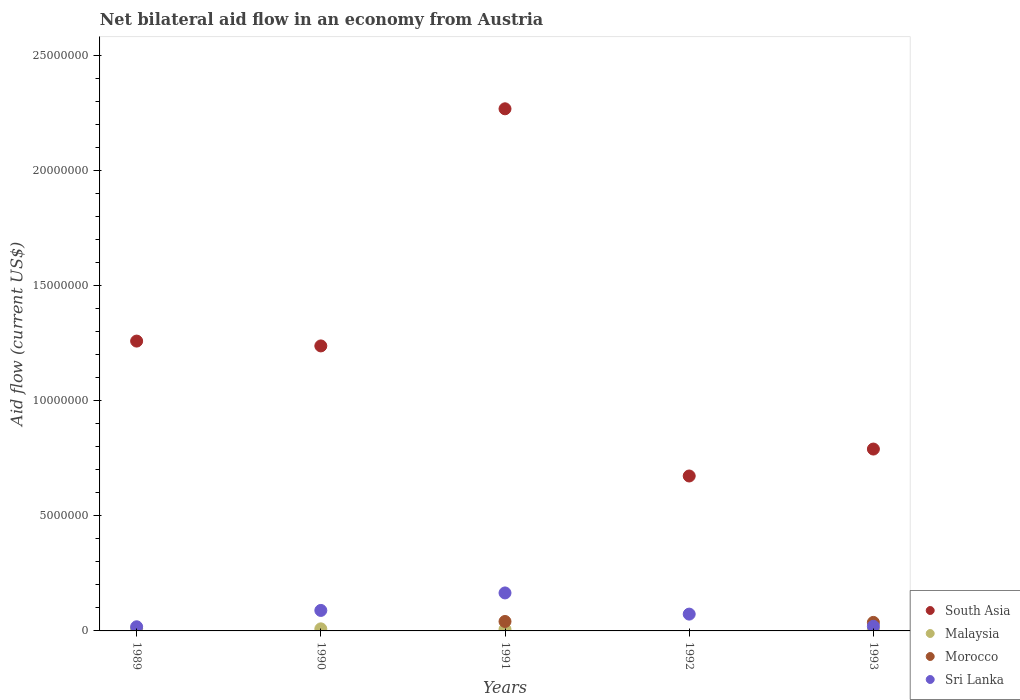Is the number of dotlines equal to the number of legend labels?
Offer a terse response. No. What is the net bilateral aid flow in Sri Lanka in 1991?
Provide a short and direct response. 1.65e+06. Across all years, what is the minimum net bilateral aid flow in South Asia?
Provide a short and direct response. 6.73e+06. What is the total net bilateral aid flow in Morocco in the graph?
Your answer should be compact. 7.80e+05. What is the difference between the net bilateral aid flow in South Asia in 1990 and that in 1991?
Your answer should be compact. -1.03e+07. What is the difference between the net bilateral aid flow in Sri Lanka in 1991 and the net bilateral aid flow in Morocco in 1990?
Keep it short and to the point. 1.65e+06. What is the average net bilateral aid flow in Malaysia per year?
Provide a short and direct response. 6.40e+04. In the year 1993, what is the difference between the net bilateral aid flow in Malaysia and net bilateral aid flow in Morocco?
Offer a terse response. -3.10e+05. In how many years, is the net bilateral aid flow in Sri Lanka greater than 16000000 US$?
Give a very brief answer. 0. What is the ratio of the net bilateral aid flow in South Asia in 1989 to that in 1990?
Keep it short and to the point. 1.02. What is the difference between the highest and the second highest net bilateral aid flow in South Asia?
Your answer should be compact. 1.01e+07. What is the difference between the highest and the lowest net bilateral aid flow in Sri Lanka?
Provide a short and direct response. 1.47e+06. In how many years, is the net bilateral aid flow in Sri Lanka greater than the average net bilateral aid flow in Sri Lanka taken over all years?
Offer a terse response. 2. How many dotlines are there?
Offer a terse response. 4. How many years are there in the graph?
Offer a terse response. 5. Are the values on the major ticks of Y-axis written in scientific E-notation?
Ensure brevity in your answer.  No. Does the graph contain grids?
Make the answer very short. No. Where does the legend appear in the graph?
Your answer should be compact. Bottom right. How many legend labels are there?
Your answer should be very brief. 4. What is the title of the graph?
Your answer should be compact. Net bilateral aid flow in an economy from Austria. What is the label or title of the X-axis?
Your answer should be very brief. Years. What is the label or title of the Y-axis?
Offer a very short reply. Aid flow (current US$). What is the Aid flow (current US$) of South Asia in 1989?
Provide a short and direct response. 1.26e+07. What is the Aid flow (current US$) of Malaysia in 1989?
Give a very brief answer. 1.00e+05. What is the Aid flow (current US$) of Morocco in 1989?
Ensure brevity in your answer.  0. What is the Aid flow (current US$) of Sri Lanka in 1989?
Provide a short and direct response. 1.80e+05. What is the Aid flow (current US$) in South Asia in 1990?
Your answer should be compact. 1.24e+07. What is the Aid flow (current US$) of Malaysia in 1990?
Give a very brief answer. 9.00e+04. What is the Aid flow (current US$) in Sri Lanka in 1990?
Provide a short and direct response. 8.90e+05. What is the Aid flow (current US$) of South Asia in 1991?
Keep it short and to the point. 2.27e+07. What is the Aid flow (current US$) in Malaysia in 1991?
Give a very brief answer. 7.00e+04. What is the Aid flow (current US$) of Sri Lanka in 1991?
Keep it short and to the point. 1.65e+06. What is the Aid flow (current US$) of South Asia in 1992?
Make the answer very short. 6.73e+06. What is the Aid flow (current US$) in Malaysia in 1992?
Offer a terse response. 0. What is the Aid flow (current US$) of Morocco in 1992?
Ensure brevity in your answer.  0. What is the Aid flow (current US$) in Sri Lanka in 1992?
Make the answer very short. 7.30e+05. What is the Aid flow (current US$) of South Asia in 1993?
Your response must be concise. 7.90e+06. What is the Aid flow (current US$) in Morocco in 1993?
Your response must be concise. 3.70e+05. Across all years, what is the maximum Aid flow (current US$) in South Asia?
Your response must be concise. 2.27e+07. Across all years, what is the maximum Aid flow (current US$) of Malaysia?
Your answer should be very brief. 1.00e+05. Across all years, what is the maximum Aid flow (current US$) of Morocco?
Your answer should be very brief. 4.10e+05. Across all years, what is the maximum Aid flow (current US$) in Sri Lanka?
Your answer should be very brief. 1.65e+06. Across all years, what is the minimum Aid flow (current US$) in South Asia?
Provide a short and direct response. 6.73e+06. What is the total Aid flow (current US$) of South Asia in the graph?
Provide a short and direct response. 6.23e+07. What is the total Aid flow (current US$) of Morocco in the graph?
Make the answer very short. 7.80e+05. What is the total Aid flow (current US$) in Sri Lanka in the graph?
Provide a short and direct response. 3.65e+06. What is the difference between the Aid flow (current US$) of South Asia in 1989 and that in 1990?
Provide a short and direct response. 2.10e+05. What is the difference between the Aid flow (current US$) in Malaysia in 1989 and that in 1990?
Offer a terse response. 10000. What is the difference between the Aid flow (current US$) of Sri Lanka in 1989 and that in 1990?
Your response must be concise. -7.10e+05. What is the difference between the Aid flow (current US$) in South Asia in 1989 and that in 1991?
Make the answer very short. -1.01e+07. What is the difference between the Aid flow (current US$) of Sri Lanka in 1989 and that in 1991?
Give a very brief answer. -1.47e+06. What is the difference between the Aid flow (current US$) in South Asia in 1989 and that in 1992?
Offer a very short reply. 5.86e+06. What is the difference between the Aid flow (current US$) of Sri Lanka in 1989 and that in 1992?
Your answer should be very brief. -5.50e+05. What is the difference between the Aid flow (current US$) of South Asia in 1989 and that in 1993?
Provide a short and direct response. 4.69e+06. What is the difference between the Aid flow (current US$) of South Asia in 1990 and that in 1991?
Offer a very short reply. -1.03e+07. What is the difference between the Aid flow (current US$) of Malaysia in 1990 and that in 1991?
Provide a short and direct response. 2.00e+04. What is the difference between the Aid flow (current US$) in Sri Lanka in 1990 and that in 1991?
Your answer should be very brief. -7.60e+05. What is the difference between the Aid flow (current US$) of South Asia in 1990 and that in 1992?
Your response must be concise. 5.65e+06. What is the difference between the Aid flow (current US$) of South Asia in 1990 and that in 1993?
Make the answer very short. 4.48e+06. What is the difference between the Aid flow (current US$) in Sri Lanka in 1990 and that in 1993?
Your answer should be compact. 6.90e+05. What is the difference between the Aid flow (current US$) of South Asia in 1991 and that in 1992?
Your answer should be compact. 1.60e+07. What is the difference between the Aid flow (current US$) of Sri Lanka in 1991 and that in 1992?
Your answer should be compact. 9.20e+05. What is the difference between the Aid flow (current US$) of South Asia in 1991 and that in 1993?
Offer a terse response. 1.48e+07. What is the difference between the Aid flow (current US$) of Malaysia in 1991 and that in 1993?
Give a very brief answer. 10000. What is the difference between the Aid flow (current US$) in Sri Lanka in 1991 and that in 1993?
Your answer should be very brief. 1.45e+06. What is the difference between the Aid flow (current US$) in South Asia in 1992 and that in 1993?
Your response must be concise. -1.17e+06. What is the difference between the Aid flow (current US$) in Sri Lanka in 1992 and that in 1993?
Your answer should be compact. 5.30e+05. What is the difference between the Aid flow (current US$) in South Asia in 1989 and the Aid flow (current US$) in Malaysia in 1990?
Make the answer very short. 1.25e+07. What is the difference between the Aid flow (current US$) of South Asia in 1989 and the Aid flow (current US$) of Sri Lanka in 1990?
Ensure brevity in your answer.  1.17e+07. What is the difference between the Aid flow (current US$) of Malaysia in 1989 and the Aid flow (current US$) of Sri Lanka in 1990?
Your answer should be very brief. -7.90e+05. What is the difference between the Aid flow (current US$) in South Asia in 1989 and the Aid flow (current US$) in Malaysia in 1991?
Give a very brief answer. 1.25e+07. What is the difference between the Aid flow (current US$) of South Asia in 1989 and the Aid flow (current US$) of Morocco in 1991?
Give a very brief answer. 1.22e+07. What is the difference between the Aid flow (current US$) in South Asia in 1989 and the Aid flow (current US$) in Sri Lanka in 1991?
Your answer should be compact. 1.09e+07. What is the difference between the Aid flow (current US$) in Malaysia in 1989 and the Aid flow (current US$) in Morocco in 1991?
Provide a short and direct response. -3.10e+05. What is the difference between the Aid flow (current US$) in Malaysia in 1989 and the Aid flow (current US$) in Sri Lanka in 1991?
Ensure brevity in your answer.  -1.55e+06. What is the difference between the Aid flow (current US$) in South Asia in 1989 and the Aid flow (current US$) in Sri Lanka in 1992?
Give a very brief answer. 1.19e+07. What is the difference between the Aid flow (current US$) in Malaysia in 1989 and the Aid flow (current US$) in Sri Lanka in 1992?
Provide a succinct answer. -6.30e+05. What is the difference between the Aid flow (current US$) in South Asia in 1989 and the Aid flow (current US$) in Malaysia in 1993?
Offer a terse response. 1.25e+07. What is the difference between the Aid flow (current US$) of South Asia in 1989 and the Aid flow (current US$) of Morocco in 1993?
Provide a succinct answer. 1.22e+07. What is the difference between the Aid flow (current US$) in South Asia in 1989 and the Aid flow (current US$) in Sri Lanka in 1993?
Keep it short and to the point. 1.24e+07. What is the difference between the Aid flow (current US$) in Malaysia in 1989 and the Aid flow (current US$) in Sri Lanka in 1993?
Your answer should be compact. -1.00e+05. What is the difference between the Aid flow (current US$) in South Asia in 1990 and the Aid flow (current US$) in Malaysia in 1991?
Provide a succinct answer. 1.23e+07. What is the difference between the Aid flow (current US$) of South Asia in 1990 and the Aid flow (current US$) of Morocco in 1991?
Make the answer very short. 1.20e+07. What is the difference between the Aid flow (current US$) of South Asia in 1990 and the Aid flow (current US$) of Sri Lanka in 1991?
Ensure brevity in your answer.  1.07e+07. What is the difference between the Aid flow (current US$) of Malaysia in 1990 and the Aid flow (current US$) of Morocco in 1991?
Make the answer very short. -3.20e+05. What is the difference between the Aid flow (current US$) of Malaysia in 1990 and the Aid flow (current US$) of Sri Lanka in 1991?
Ensure brevity in your answer.  -1.56e+06. What is the difference between the Aid flow (current US$) of South Asia in 1990 and the Aid flow (current US$) of Sri Lanka in 1992?
Keep it short and to the point. 1.16e+07. What is the difference between the Aid flow (current US$) of Malaysia in 1990 and the Aid flow (current US$) of Sri Lanka in 1992?
Make the answer very short. -6.40e+05. What is the difference between the Aid flow (current US$) in South Asia in 1990 and the Aid flow (current US$) in Malaysia in 1993?
Your answer should be compact. 1.23e+07. What is the difference between the Aid flow (current US$) of South Asia in 1990 and the Aid flow (current US$) of Morocco in 1993?
Your response must be concise. 1.20e+07. What is the difference between the Aid flow (current US$) of South Asia in 1990 and the Aid flow (current US$) of Sri Lanka in 1993?
Offer a very short reply. 1.22e+07. What is the difference between the Aid flow (current US$) in Malaysia in 1990 and the Aid flow (current US$) in Morocco in 1993?
Give a very brief answer. -2.80e+05. What is the difference between the Aid flow (current US$) in Malaysia in 1990 and the Aid flow (current US$) in Sri Lanka in 1993?
Provide a short and direct response. -1.10e+05. What is the difference between the Aid flow (current US$) of South Asia in 1991 and the Aid flow (current US$) of Sri Lanka in 1992?
Provide a succinct answer. 2.20e+07. What is the difference between the Aid flow (current US$) in Malaysia in 1991 and the Aid flow (current US$) in Sri Lanka in 1992?
Your answer should be very brief. -6.60e+05. What is the difference between the Aid flow (current US$) of Morocco in 1991 and the Aid flow (current US$) of Sri Lanka in 1992?
Provide a succinct answer. -3.20e+05. What is the difference between the Aid flow (current US$) in South Asia in 1991 and the Aid flow (current US$) in Malaysia in 1993?
Give a very brief answer. 2.26e+07. What is the difference between the Aid flow (current US$) of South Asia in 1991 and the Aid flow (current US$) of Morocco in 1993?
Offer a terse response. 2.23e+07. What is the difference between the Aid flow (current US$) of South Asia in 1991 and the Aid flow (current US$) of Sri Lanka in 1993?
Offer a terse response. 2.25e+07. What is the difference between the Aid flow (current US$) in Malaysia in 1991 and the Aid flow (current US$) in Sri Lanka in 1993?
Keep it short and to the point. -1.30e+05. What is the difference between the Aid flow (current US$) of Morocco in 1991 and the Aid flow (current US$) of Sri Lanka in 1993?
Offer a very short reply. 2.10e+05. What is the difference between the Aid flow (current US$) of South Asia in 1992 and the Aid flow (current US$) of Malaysia in 1993?
Offer a very short reply. 6.67e+06. What is the difference between the Aid flow (current US$) of South Asia in 1992 and the Aid flow (current US$) of Morocco in 1993?
Offer a terse response. 6.36e+06. What is the difference between the Aid flow (current US$) in South Asia in 1992 and the Aid flow (current US$) in Sri Lanka in 1993?
Offer a terse response. 6.53e+06. What is the average Aid flow (current US$) of South Asia per year?
Offer a very short reply. 1.25e+07. What is the average Aid flow (current US$) of Malaysia per year?
Your answer should be compact. 6.40e+04. What is the average Aid flow (current US$) in Morocco per year?
Keep it short and to the point. 1.56e+05. What is the average Aid flow (current US$) of Sri Lanka per year?
Your answer should be very brief. 7.30e+05. In the year 1989, what is the difference between the Aid flow (current US$) in South Asia and Aid flow (current US$) in Malaysia?
Ensure brevity in your answer.  1.25e+07. In the year 1989, what is the difference between the Aid flow (current US$) of South Asia and Aid flow (current US$) of Sri Lanka?
Your answer should be compact. 1.24e+07. In the year 1990, what is the difference between the Aid flow (current US$) in South Asia and Aid flow (current US$) in Malaysia?
Provide a succinct answer. 1.23e+07. In the year 1990, what is the difference between the Aid flow (current US$) of South Asia and Aid flow (current US$) of Sri Lanka?
Offer a terse response. 1.15e+07. In the year 1990, what is the difference between the Aid flow (current US$) of Malaysia and Aid flow (current US$) of Sri Lanka?
Make the answer very short. -8.00e+05. In the year 1991, what is the difference between the Aid flow (current US$) of South Asia and Aid flow (current US$) of Malaysia?
Your answer should be compact. 2.26e+07. In the year 1991, what is the difference between the Aid flow (current US$) of South Asia and Aid flow (current US$) of Morocco?
Offer a very short reply. 2.23e+07. In the year 1991, what is the difference between the Aid flow (current US$) in South Asia and Aid flow (current US$) in Sri Lanka?
Offer a very short reply. 2.10e+07. In the year 1991, what is the difference between the Aid flow (current US$) of Malaysia and Aid flow (current US$) of Morocco?
Give a very brief answer. -3.40e+05. In the year 1991, what is the difference between the Aid flow (current US$) of Malaysia and Aid flow (current US$) of Sri Lanka?
Ensure brevity in your answer.  -1.58e+06. In the year 1991, what is the difference between the Aid flow (current US$) of Morocco and Aid flow (current US$) of Sri Lanka?
Ensure brevity in your answer.  -1.24e+06. In the year 1992, what is the difference between the Aid flow (current US$) of South Asia and Aid flow (current US$) of Sri Lanka?
Give a very brief answer. 6.00e+06. In the year 1993, what is the difference between the Aid flow (current US$) of South Asia and Aid flow (current US$) of Malaysia?
Keep it short and to the point. 7.84e+06. In the year 1993, what is the difference between the Aid flow (current US$) of South Asia and Aid flow (current US$) of Morocco?
Offer a terse response. 7.53e+06. In the year 1993, what is the difference between the Aid flow (current US$) in South Asia and Aid flow (current US$) in Sri Lanka?
Your answer should be compact. 7.70e+06. In the year 1993, what is the difference between the Aid flow (current US$) in Malaysia and Aid flow (current US$) in Morocco?
Make the answer very short. -3.10e+05. In the year 1993, what is the difference between the Aid flow (current US$) of Malaysia and Aid flow (current US$) of Sri Lanka?
Offer a terse response. -1.40e+05. What is the ratio of the Aid flow (current US$) of South Asia in 1989 to that in 1990?
Provide a succinct answer. 1.02. What is the ratio of the Aid flow (current US$) in Malaysia in 1989 to that in 1990?
Your answer should be compact. 1.11. What is the ratio of the Aid flow (current US$) of Sri Lanka in 1989 to that in 1990?
Provide a short and direct response. 0.2. What is the ratio of the Aid flow (current US$) of South Asia in 1989 to that in 1991?
Your answer should be very brief. 0.56. What is the ratio of the Aid flow (current US$) in Malaysia in 1989 to that in 1991?
Offer a terse response. 1.43. What is the ratio of the Aid flow (current US$) in Sri Lanka in 1989 to that in 1991?
Make the answer very short. 0.11. What is the ratio of the Aid flow (current US$) of South Asia in 1989 to that in 1992?
Make the answer very short. 1.87. What is the ratio of the Aid flow (current US$) in Sri Lanka in 1989 to that in 1992?
Your answer should be very brief. 0.25. What is the ratio of the Aid flow (current US$) of South Asia in 1989 to that in 1993?
Keep it short and to the point. 1.59. What is the ratio of the Aid flow (current US$) of Malaysia in 1989 to that in 1993?
Give a very brief answer. 1.67. What is the ratio of the Aid flow (current US$) in Sri Lanka in 1989 to that in 1993?
Ensure brevity in your answer.  0.9. What is the ratio of the Aid flow (current US$) in South Asia in 1990 to that in 1991?
Your response must be concise. 0.55. What is the ratio of the Aid flow (current US$) of Malaysia in 1990 to that in 1991?
Your response must be concise. 1.29. What is the ratio of the Aid flow (current US$) in Sri Lanka in 1990 to that in 1991?
Your answer should be compact. 0.54. What is the ratio of the Aid flow (current US$) in South Asia in 1990 to that in 1992?
Your answer should be compact. 1.84. What is the ratio of the Aid flow (current US$) in Sri Lanka in 1990 to that in 1992?
Offer a terse response. 1.22. What is the ratio of the Aid flow (current US$) in South Asia in 1990 to that in 1993?
Ensure brevity in your answer.  1.57. What is the ratio of the Aid flow (current US$) of Malaysia in 1990 to that in 1993?
Ensure brevity in your answer.  1.5. What is the ratio of the Aid flow (current US$) in Sri Lanka in 1990 to that in 1993?
Your answer should be very brief. 4.45. What is the ratio of the Aid flow (current US$) in South Asia in 1991 to that in 1992?
Your response must be concise. 3.37. What is the ratio of the Aid flow (current US$) of Sri Lanka in 1991 to that in 1992?
Your answer should be compact. 2.26. What is the ratio of the Aid flow (current US$) in South Asia in 1991 to that in 1993?
Your answer should be very brief. 2.87. What is the ratio of the Aid flow (current US$) of Morocco in 1991 to that in 1993?
Offer a terse response. 1.11. What is the ratio of the Aid flow (current US$) in Sri Lanka in 1991 to that in 1993?
Provide a short and direct response. 8.25. What is the ratio of the Aid flow (current US$) in South Asia in 1992 to that in 1993?
Provide a succinct answer. 0.85. What is the ratio of the Aid flow (current US$) of Sri Lanka in 1992 to that in 1993?
Your answer should be compact. 3.65. What is the difference between the highest and the second highest Aid flow (current US$) in South Asia?
Provide a succinct answer. 1.01e+07. What is the difference between the highest and the second highest Aid flow (current US$) in Sri Lanka?
Make the answer very short. 7.60e+05. What is the difference between the highest and the lowest Aid flow (current US$) of South Asia?
Your response must be concise. 1.60e+07. What is the difference between the highest and the lowest Aid flow (current US$) of Morocco?
Offer a terse response. 4.10e+05. What is the difference between the highest and the lowest Aid flow (current US$) in Sri Lanka?
Give a very brief answer. 1.47e+06. 